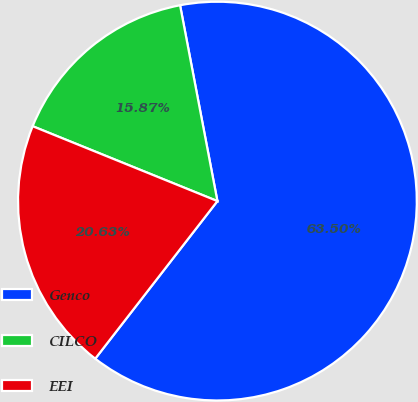<chart> <loc_0><loc_0><loc_500><loc_500><pie_chart><fcel>Genco<fcel>CILCO<fcel>EEI<nl><fcel>63.49%<fcel>15.87%<fcel>20.63%<nl></chart> 